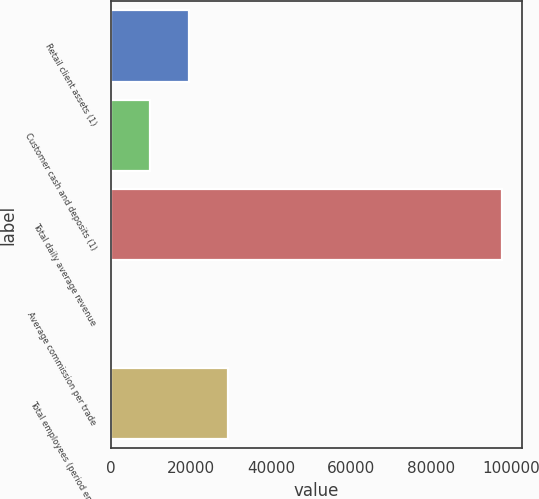<chart> <loc_0><loc_0><loc_500><loc_500><bar_chart><fcel>Retail client assets (1)<fcel>Customer cash and deposits (1)<fcel>Total daily average revenue<fcel>Average commission per trade<fcel>Total employees (period end)<nl><fcel>19559.1<fcel>9786.44<fcel>97740<fcel>13.82<fcel>29331.7<nl></chart> 